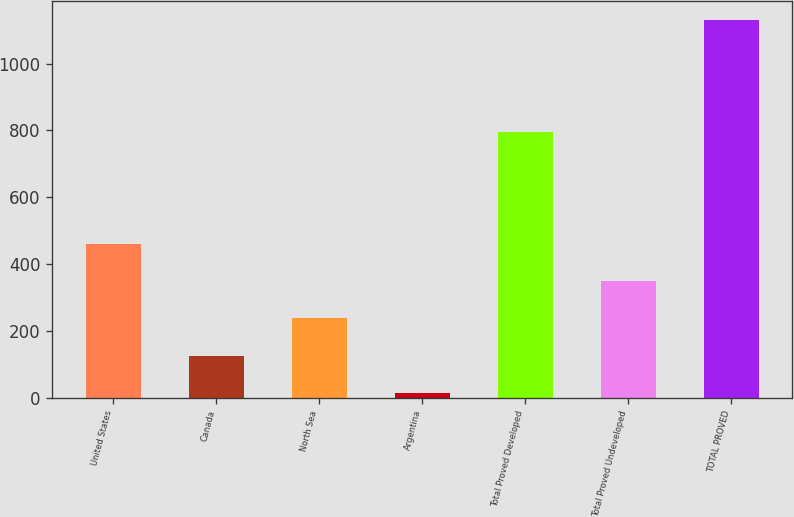Convert chart to OTSL. <chart><loc_0><loc_0><loc_500><loc_500><bar_chart><fcel>United States<fcel>Canada<fcel>North Sea<fcel>Argentina<fcel>Total Proved Developed<fcel>Total Proved Undeveloped<fcel>TOTAL PROVED<nl><fcel>460.8<fcel>125.7<fcel>237.4<fcel>14<fcel>795<fcel>349.1<fcel>1131<nl></chart> 